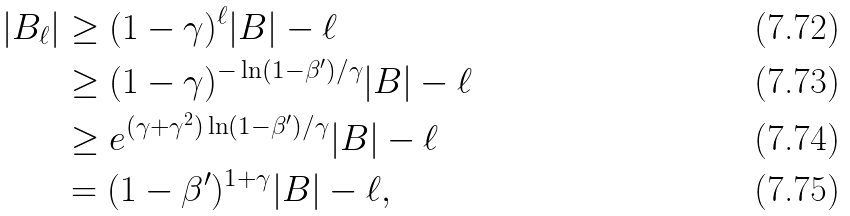Convert formula to latex. <formula><loc_0><loc_0><loc_500><loc_500>| B _ { \ell } | & \geq ( 1 - \gamma ) ^ { \ell } | B | - \ell \\ & \geq ( 1 - \gamma ) ^ { - \ln ( 1 - \beta ^ { \prime } ) / \gamma } | B | - \ell \\ & \geq e ^ { ( \gamma + \gamma ^ { 2 } ) \ln ( 1 - \beta ^ { \prime } ) / \gamma } | B | - \ell \\ & = ( 1 - \beta ^ { \prime } ) ^ { 1 + \gamma } | B | - \ell ,</formula> 